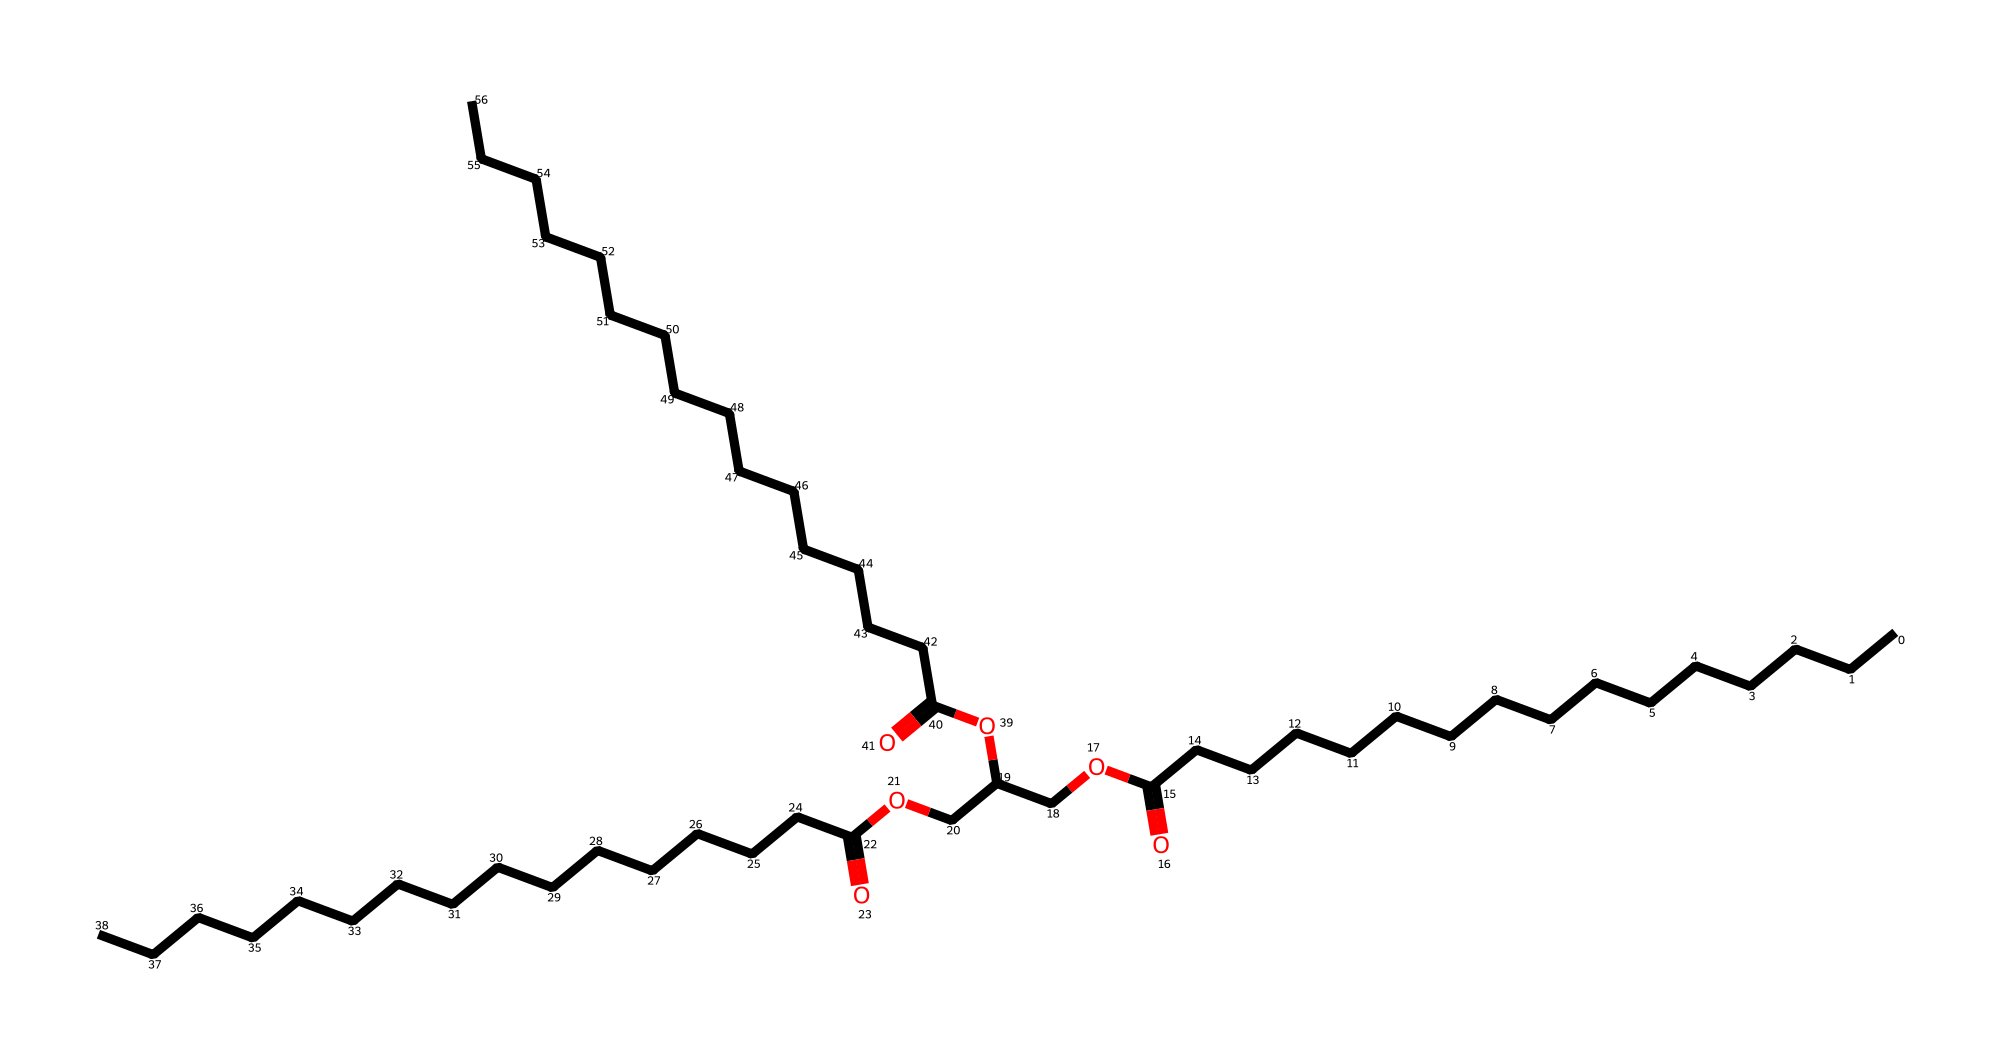What is the primary functional group present in this chemical? The chemical contains a carboxylic acid functional group, as indicated by the presence of a –COOH segment in the structural representation.
Answer: carboxylic acid How many carbon atoms are in the main carbon chain? By counting the number of carbon atoms in the longest continuous chain, I find there are 24 carbon atoms (the straight chain of carbon atoms), as denoted by the initial C's in the SMILES.
Answer: 24 What type of lipid is suggested by the structure of this chemical? The structure indicates it is a triglyceride lipid because it contains glycerol and three fatty acid chains, a typical configuration for this type of lipid.
Answer: triglyceride What does the presence of multiple ester groups in this chemical imply about its properties? Multiple ester groups imply that it has emulsifying properties, which can help blend oil and water, making it suitable for cosmetic applications in hair care products.
Answer: emulsifying properties What aspect of this molecule relates to its means of hydration in hair care? The ester groups contribute to its ability to attract and hold water molecules, enhancing moisture retention in hair care formulations.
Answer: moisture retention 